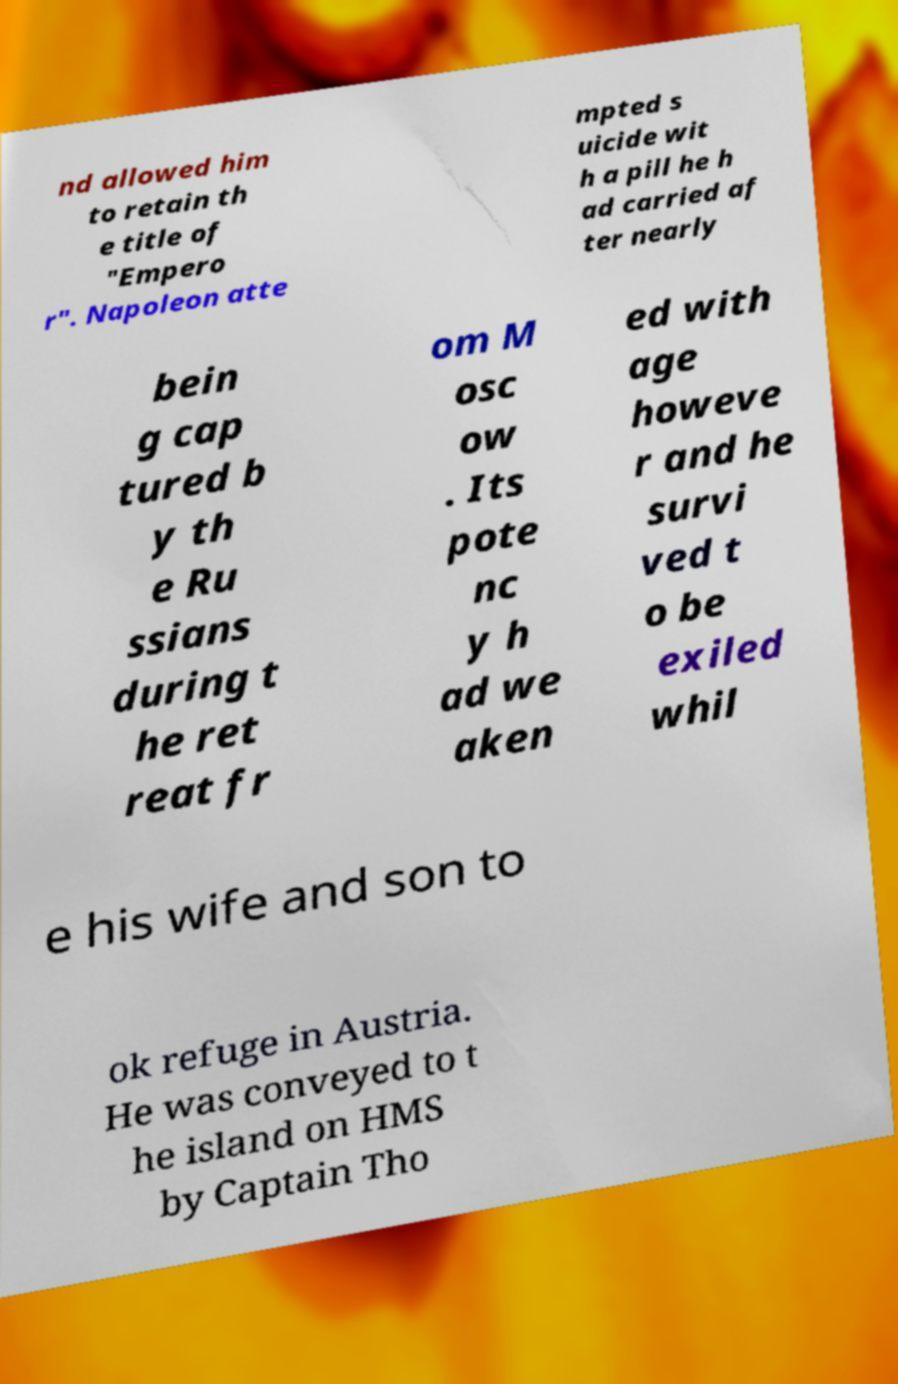Can you read and provide the text displayed in the image?This photo seems to have some interesting text. Can you extract and type it out for me? nd allowed him to retain th e title of "Empero r". Napoleon atte mpted s uicide wit h a pill he h ad carried af ter nearly bein g cap tured b y th e Ru ssians during t he ret reat fr om M osc ow . Its pote nc y h ad we aken ed with age howeve r and he survi ved t o be exiled whil e his wife and son to ok refuge in Austria. He was conveyed to t he island on HMS by Captain Tho 